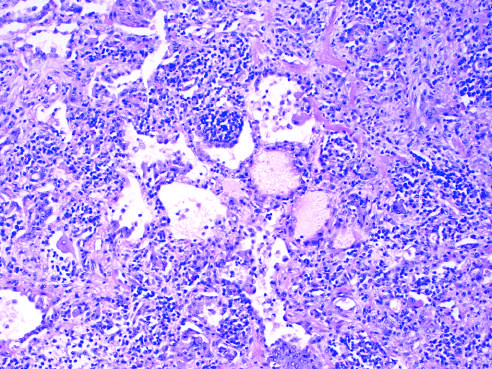re the thickened alveolar walls infiltrated with lymphocytes and some plasma cells, which spill over into alveolar spaces?
Answer the question using a single word or phrase. Yes 